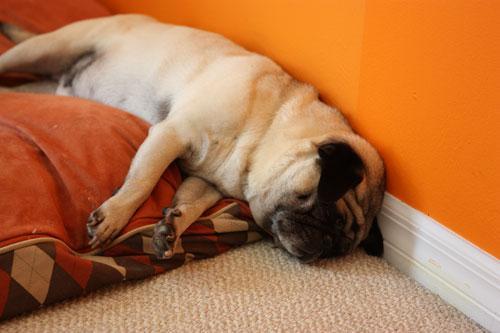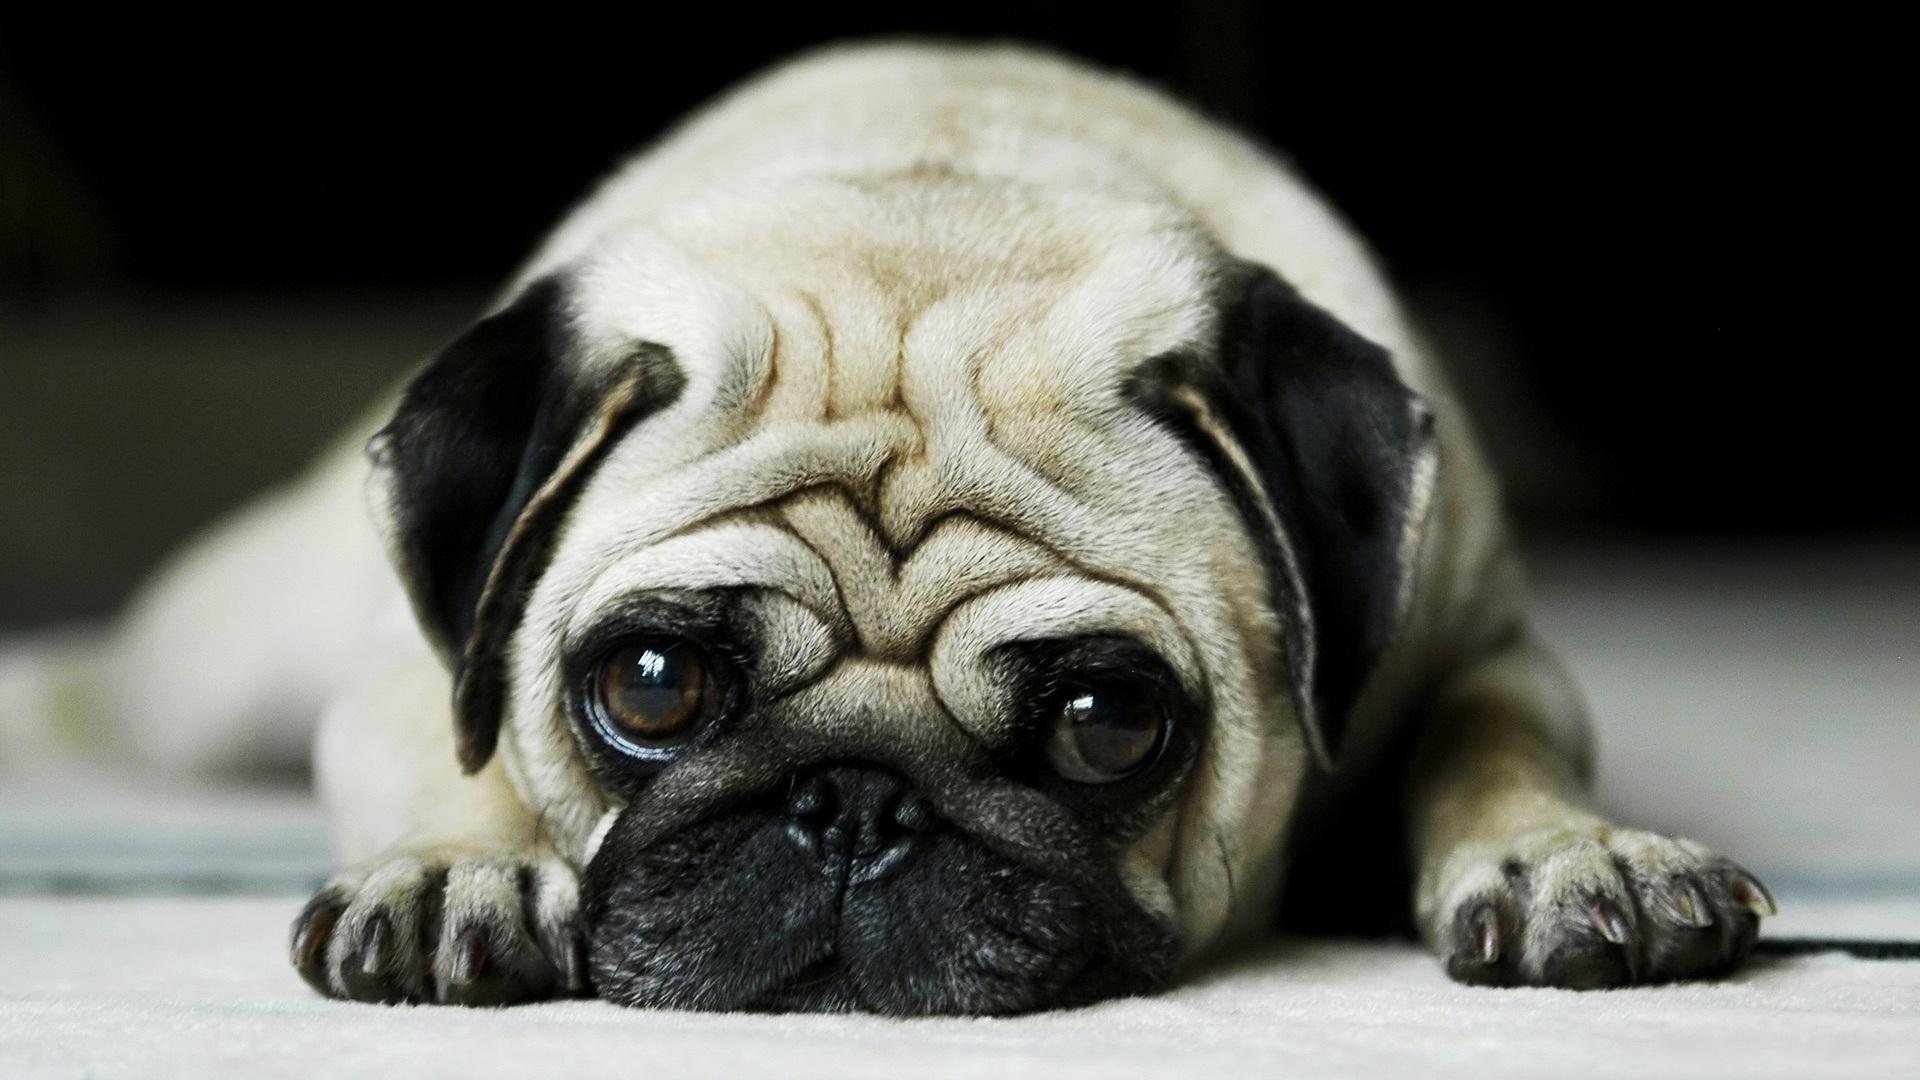The first image is the image on the left, the second image is the image on the right. Given the left and right images, does the statement "One of the images has more than one dog." hold true? Answer yes or no. No. The first image is the image on the left, the second image is the image on the right. Analyze the images presented: Is the assertion "Each image contains one buff-beige pug with a dark muzzle, and one pug is on an orange cushion while the other is lying flat on its belly." valid? Answer yes or no. Yes. 